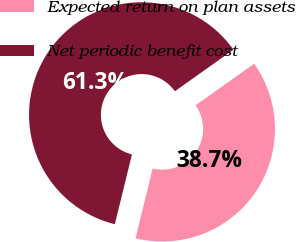Convert chart. <chart><loc_0><loc_0><loc_500><loc_500><pie_chart><fcel>Expected return on plan assets<fcel>Net periodic benefit cost<nl><fcel>38.65%<fcel>61.35%<nl></chart> 